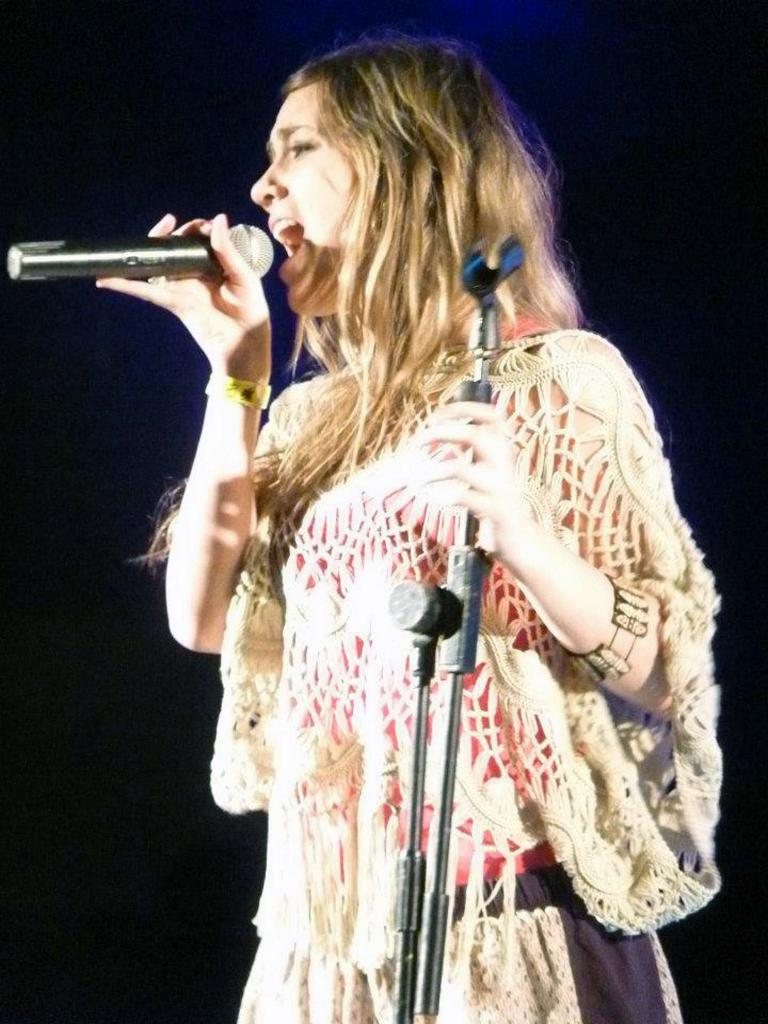Who is the main subject in the image? There is a woman in the image. What is the woman doing in the image? The woman is singing. What objects is the woman holding in the image? The woman is holding a microphone and a stand. What type of apparatus is the woman using to read books in the image? There is no apparatus for reading books present in the image, nor is the woman reading books. 